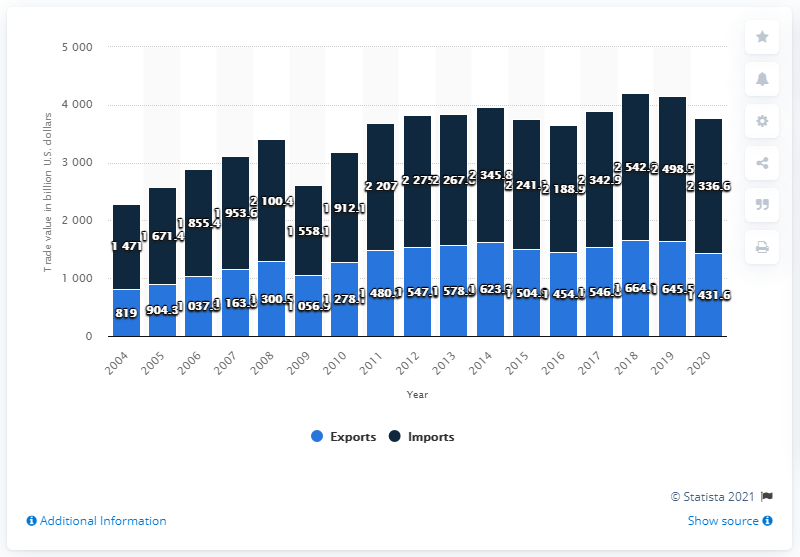Draw attention to some important aspects in this diagram. In 2020, the value of goods exported from the United States to other countries was 1431.6 billion dollars. In 2020, the United States imported goods worth $2336.6 million in dollars. 